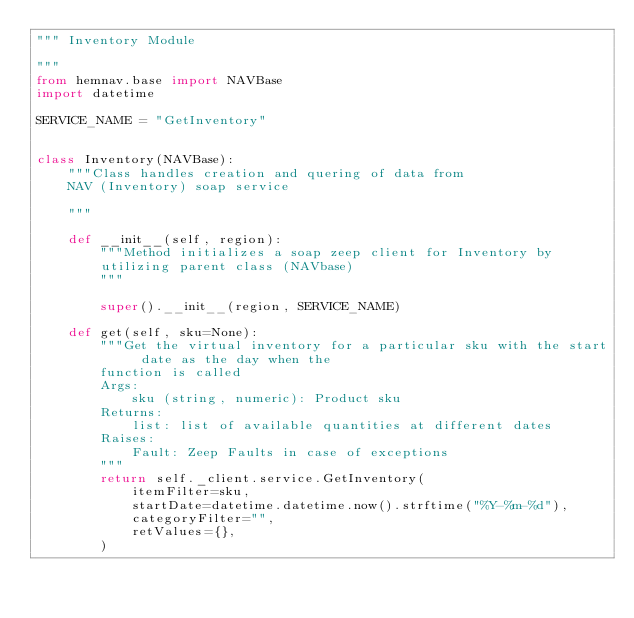<code> <loc_0><loc_0><loc_500><loc_500><_Python_>""" Inventory Module

"""
from hemnav.base import NAVBase
import datetime

SERVICE_NAME = "GetInventory"


class Inventory(NAVBase):
    """Class handles creation and quering of data from
    NAV (Inventory) soap service

    """

    def __init__(self, region):
        """Method initializes a soap zeep client for Inventory by
        utilizing parent class (NAVbase)
        """

        super().__init__(region, SERVICE_NAME)

    def get(self, sku=None):
        """Get the virtual inventory for a particular sku with the start date as the day when the
        function is called
        Args:
            sku (string, numeric): Product sku
        Returns:
            list: list of available quantities at different dates
        Raises:
            Fault: Zeep Faults in case of exceptions
        """
        return self._client.service.GetInventory(
            itemFilter=sku,
            startDate=datetime.datetime.now().strftime("%Y-%m-%d"),
            categoryFilter="",
            retValues={},
        )
</code> 